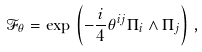<formula> <loc_0><loc_0><loc_500><loc_500>\mathcal { F } _ { \theta } = \exp \, \left ( - \frac { i } { 4 } \theta ^ { i j } \Pi _ { i } \wedge \Pi _ { j } \right ) \, ,</formula> 